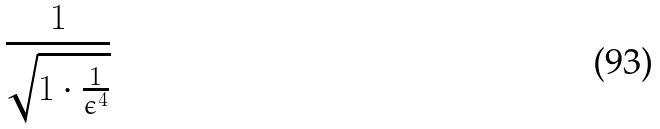Convert formula to latex. <formula><loc_0><loc_0><loc_500><loc_500>\frac { 1 } { \sqrt { 1 \cdot \frac { 1 } { \epsilon ^ { 4 } } } }</formula> 